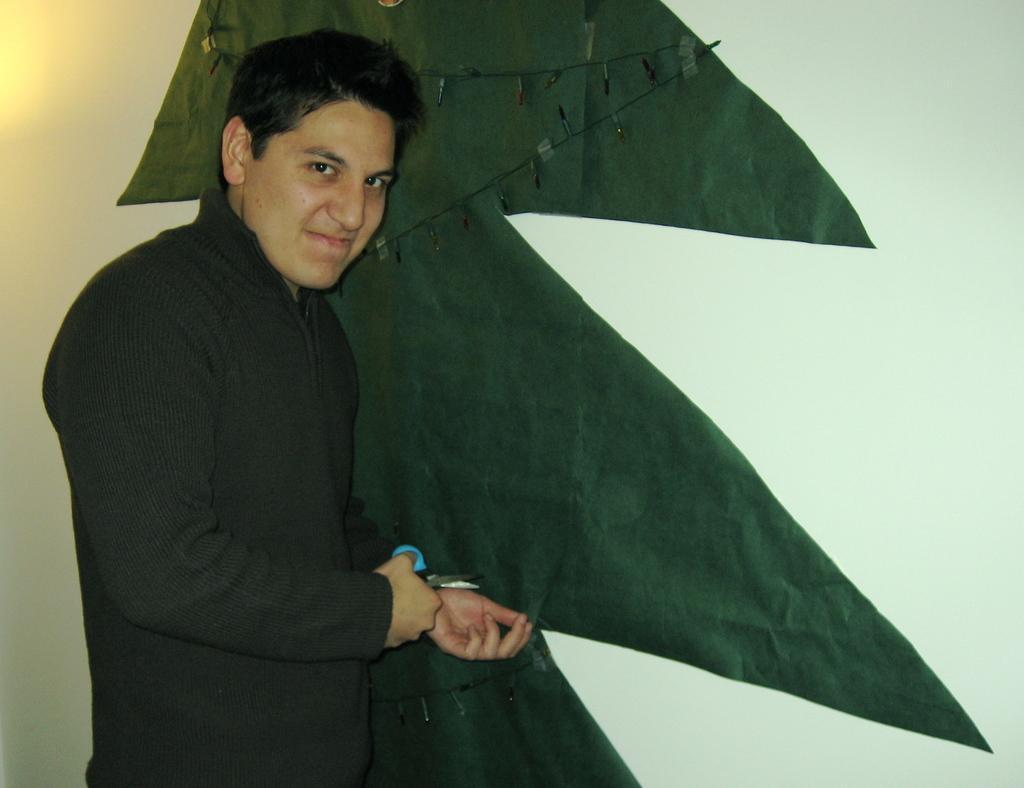Can you describe this image briefly? In this picture there is a boy who is holding a scissor in his hand, he is cutting the shape of a tree. 